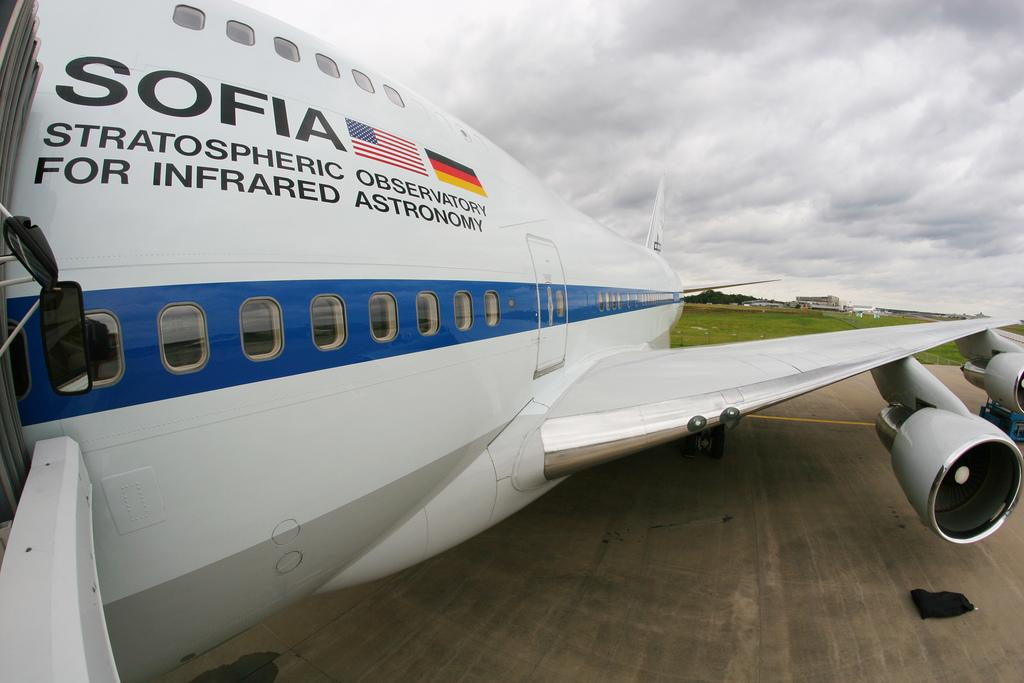<image>
Give a short and clear explanation of the subsequent image. A Sofia airplane is at the gate with the jetway attached. 